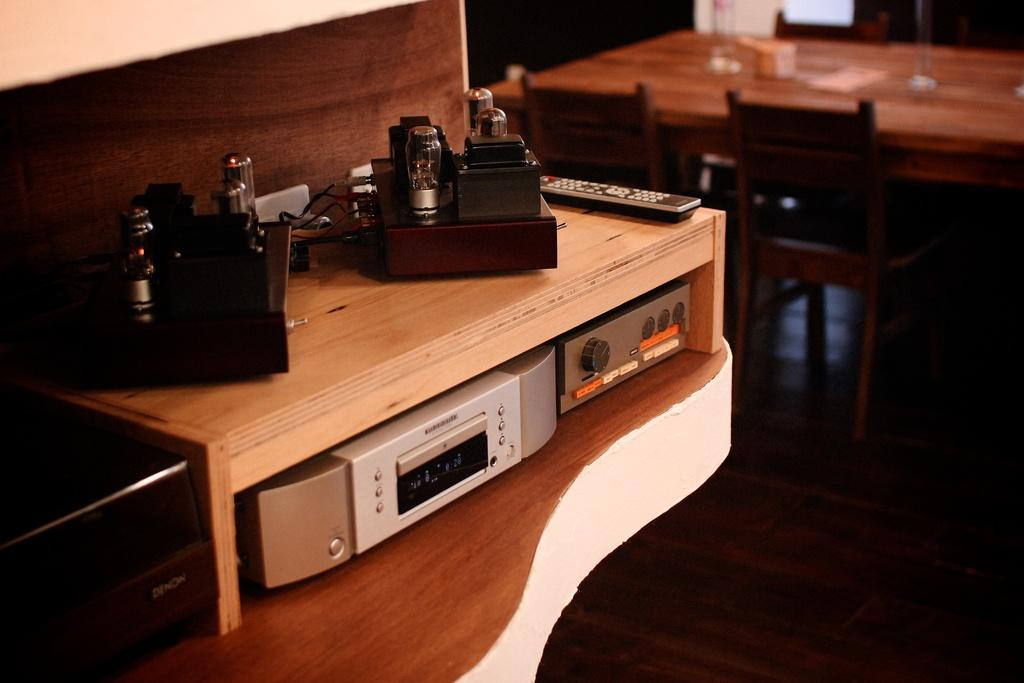How many people are visible in the image? There are many players in the image. What type of electronic components can be seen in the image? There are transistors in the image. What kind of electronic equipment is present in the image? There is electronic equipment in the image. Where is the remote located in the image? The remote is present on a table in the image. What type of furniture is visible in the background of the image? There is a dining table in the background of the image, and chairs are around the dining table. What material is the floor made of in the image? The floor is made of wood. Can you tell me the name of the person who signed the receipt in the image? There is no receipt present in the image. What type of wrist accessory is the player wearing in the image? There is no wrist accessory mentioned or visible in the image. 